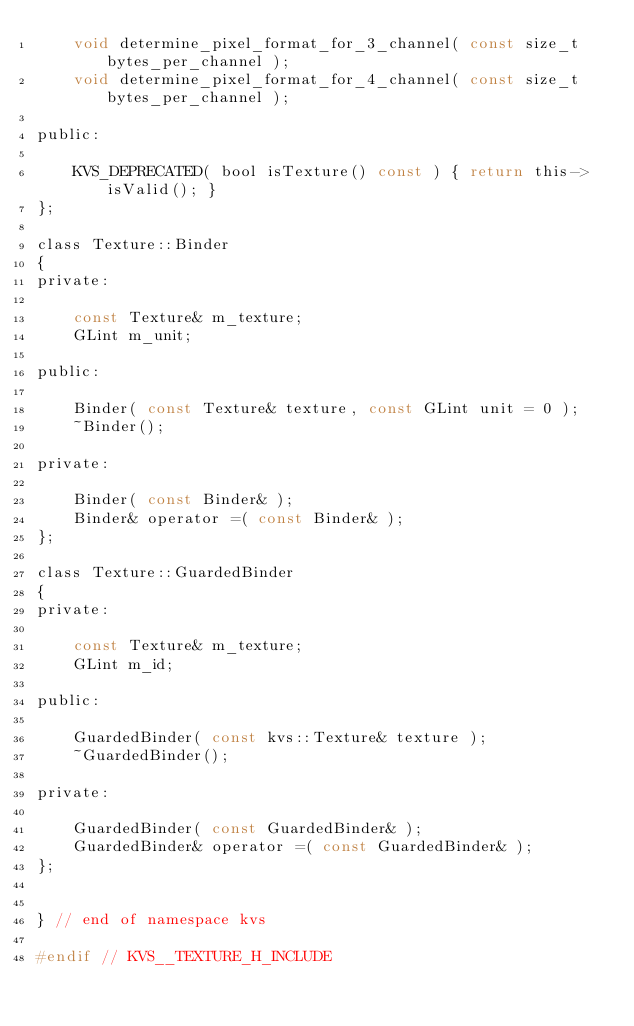Convert code to text. <code><loc_0><loc_0><loc_500><loc_500><_C_>    void determine_pixel_format_for_3_channel( const size_t bytes_per_channel );
    void determine_pixel_format_for_4_channel( const size_t bytes_per_channel );

public:

    KVS_DEPRECATED( bool isTexture() const ) { return this->isValid(); }
};

class Texture::Binder
{
private:

    const Texture& m_texture;
    GLint m_unit;

public:

    Binder( const Texture& texture, const GLint unit = 0 );
    ~Binder();

private:

    Binder( const Binder& );
    Binder& operator =( const Binder& );
};

class Texture::GuardedBinder
{
private:

    const Texture& m_texture;
    GLint m_id;

public:

    GuardedBinder( const kvs::Texture& texture );
    ~GuardedBinder();

private:

    GuardedBinder( const GuardedBinder& );
    GuardedBinder& operator =( const GuardedBinder& );
};


} // end of namespace kvs

#endif // KVS__TEXTURE_H_INCLUDE
</code> 